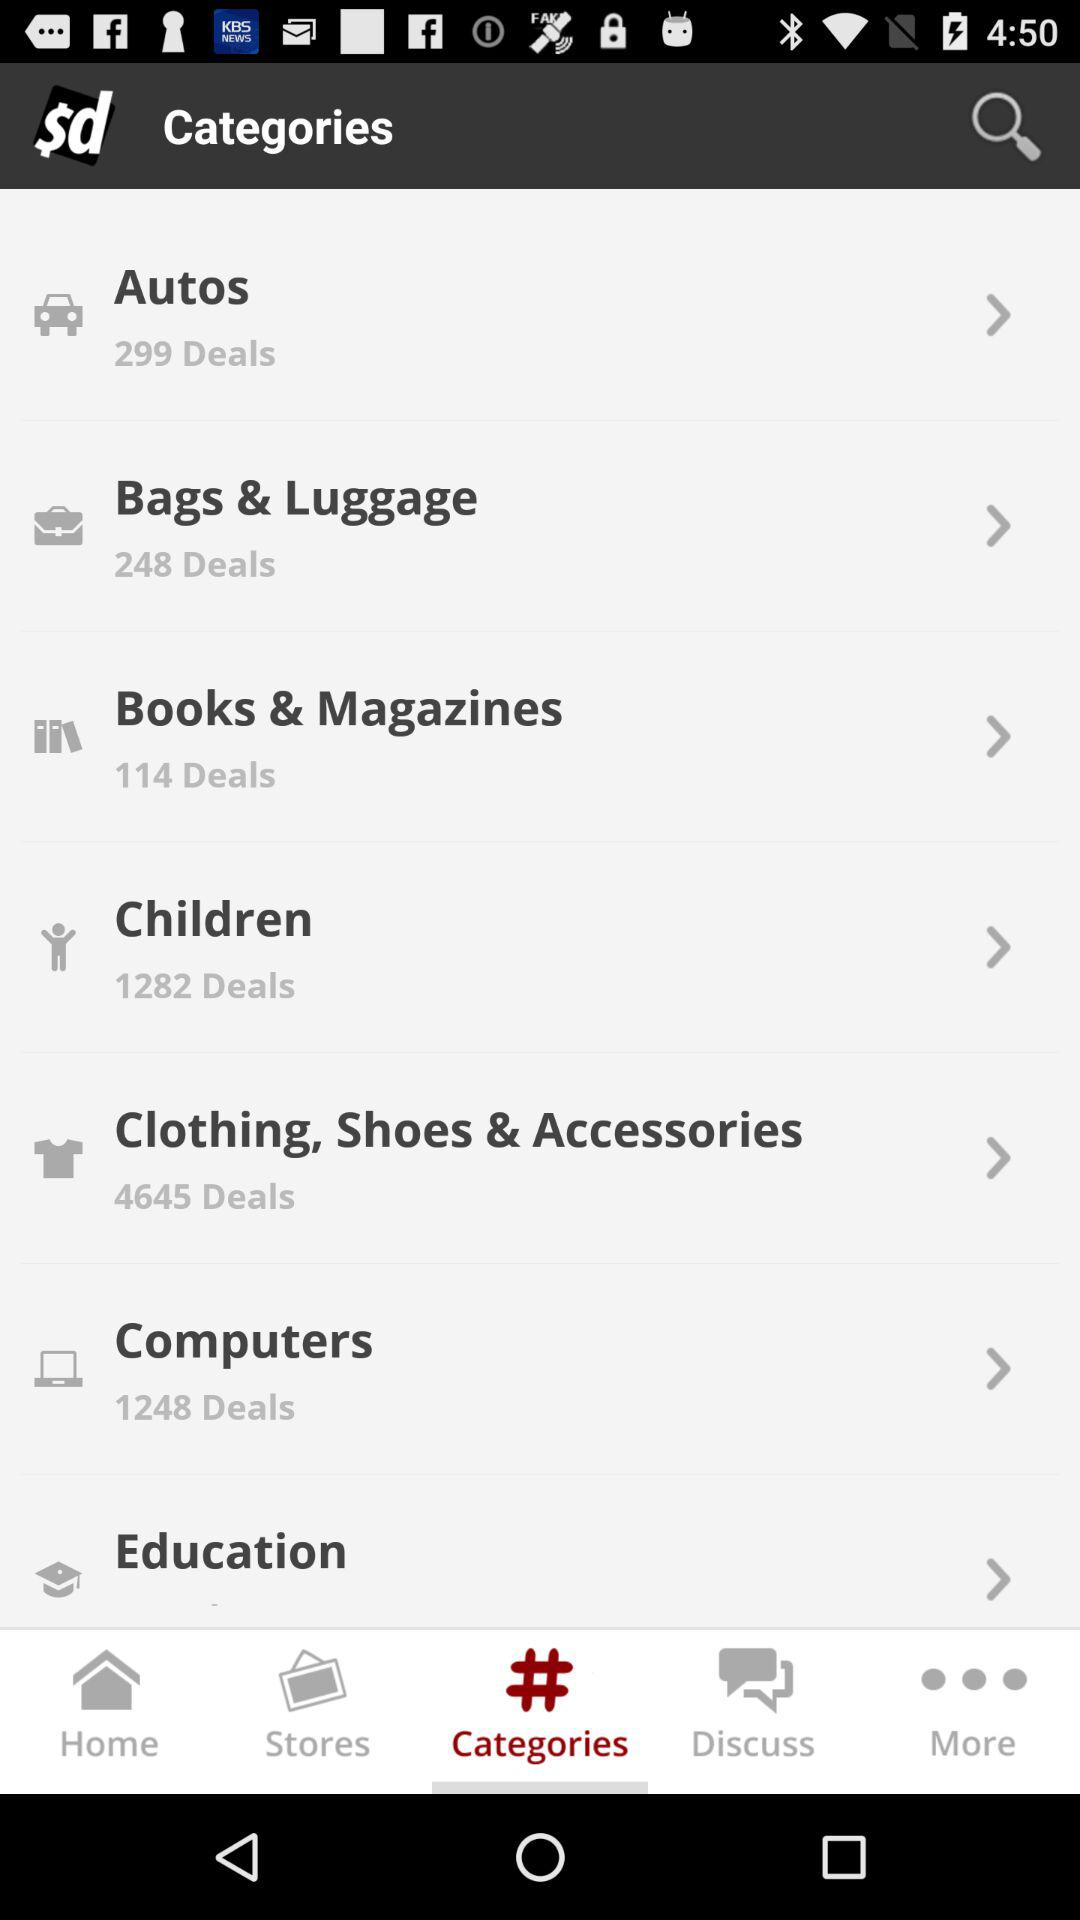How many deals are there in "Clothing, Shoes & Accessories"? There are 4645 deals. 